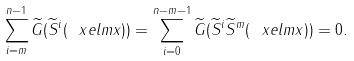<formula> <loc_0><loc_0><loc_500><loc_500>\sum _ { i = m } ^ { n - 1 } \widetilde { G } ( \widetilde { S } ^ { i } ( \ x e l m { x } ) ) = \sum _ { i = 0 } ^ { n - m - 1 } \widetilde { G } ( \widetilde { S } ^ { i } \widetilde { S } ^ { m } ( \ x e l m { x } ) ) = 0 .</formula> 